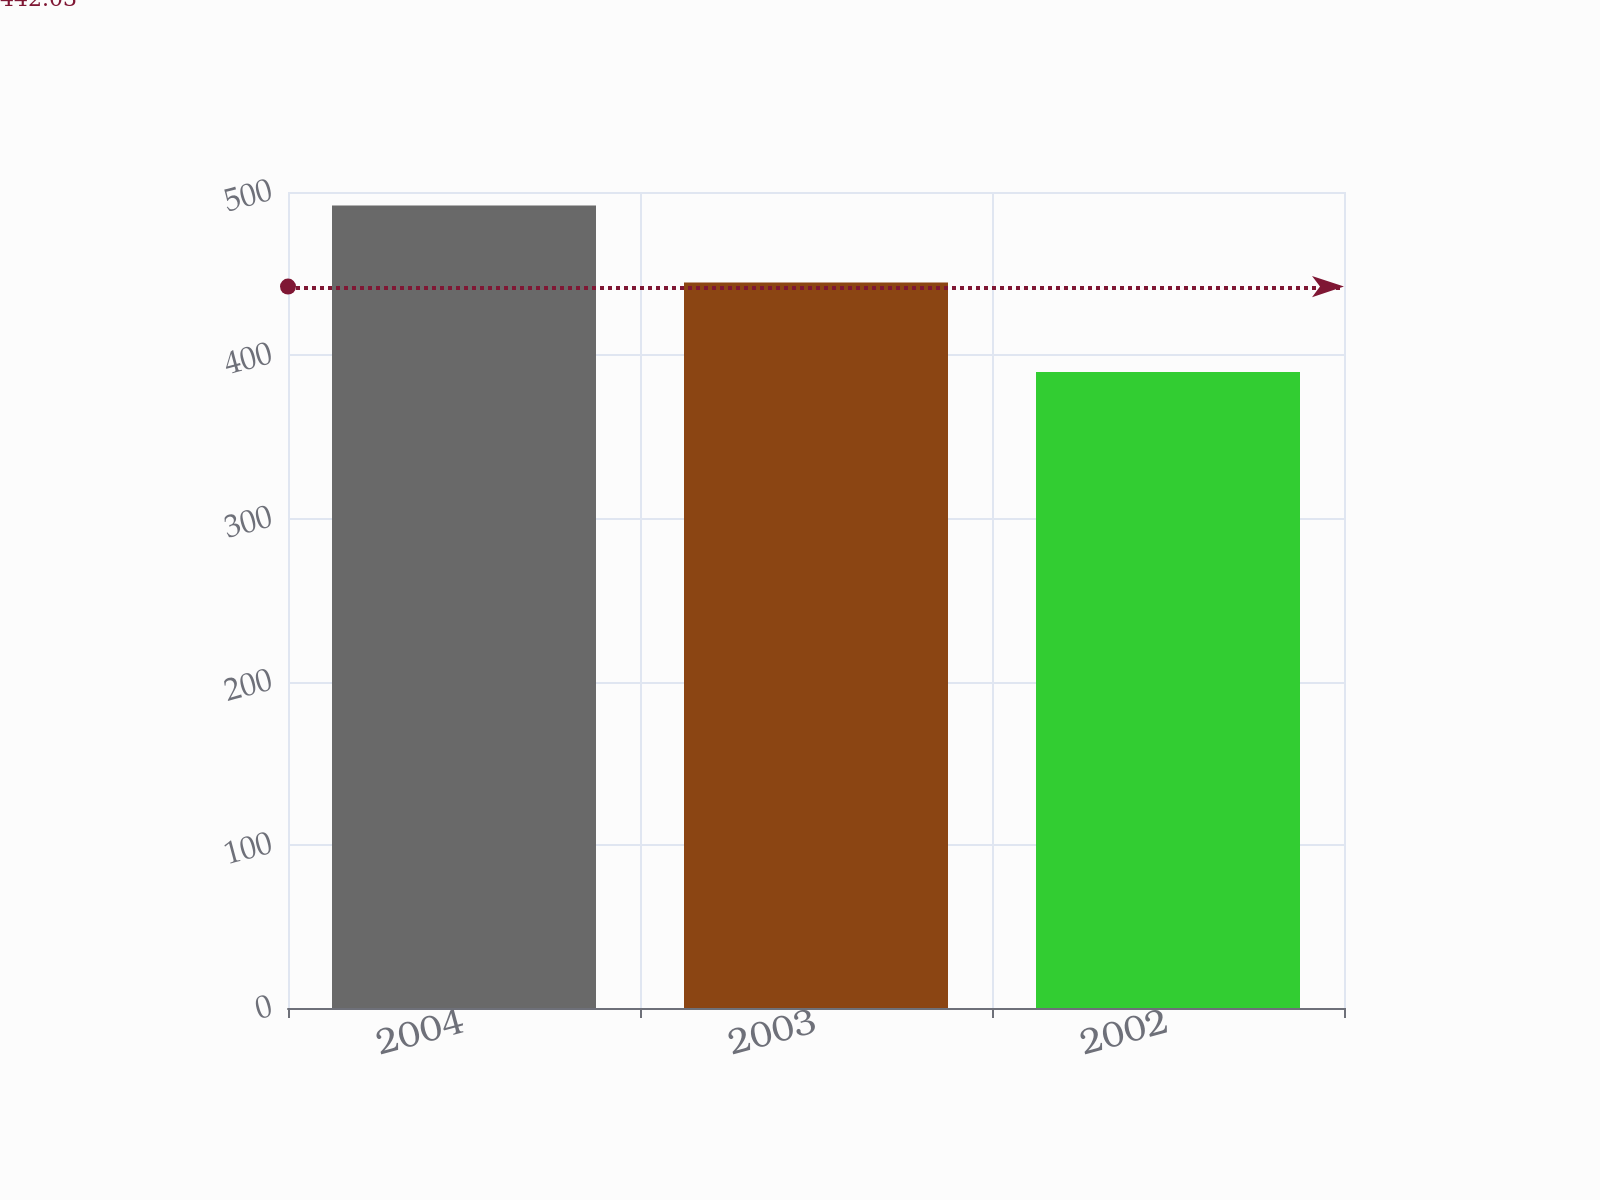Convert chart to OTSL. <chart><loc_0><loc_0><loc_500><loc_500><bar_chart><fcel>2004<fcel>2003<fcel>2002<nl><fcel>491.8<fcel>444.6<fcel>389.7<nl></chart> 